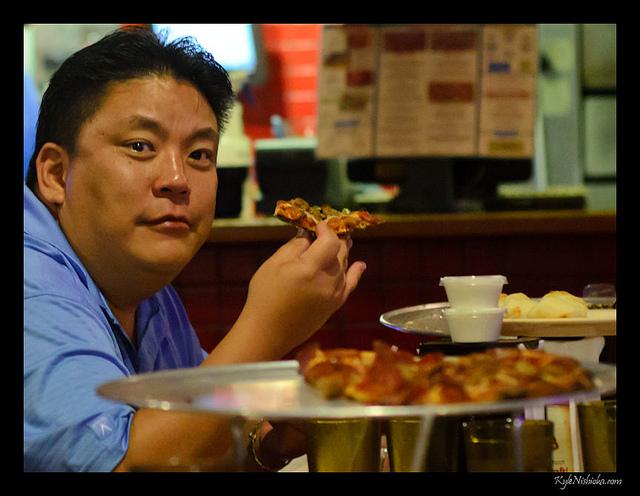What color is the plate?
Be succinct. Silver. What color is his shirt?
Write a very short answer. Blue. How many people are visible in the image?
Keep it brief. 1. Are there vegetarian options available?
Short answer required. No. Is the man real or fake?
Answer briefly. Real. How many calories in the pizza?
Quick response, please. 350. Which food we can see in this picture?
Keep it brief. Pizza. Who is eating pizza?
Quick response, please. Man. 